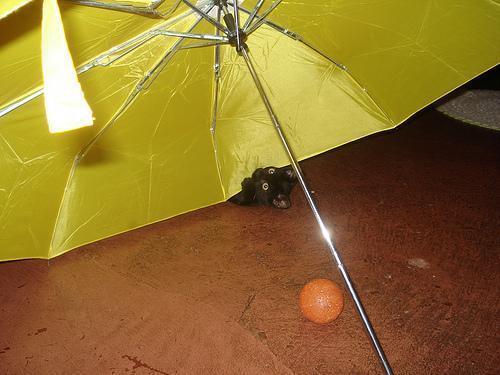How many people are there?
Give a very brief answer. 0. 